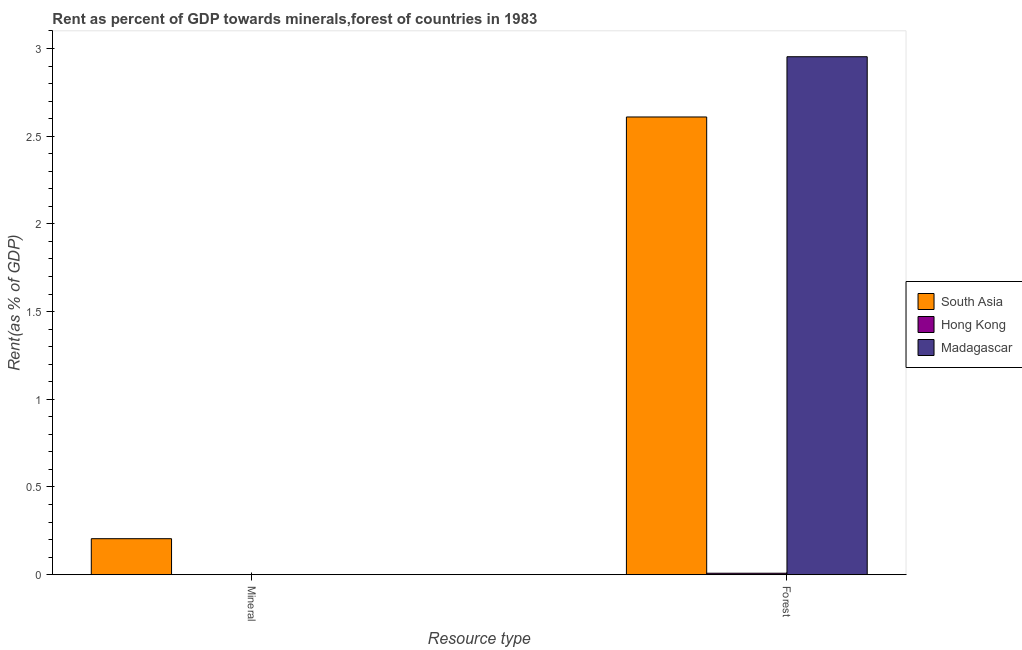How many different coloured bars are there?
Your response must be concise. 3. How many groups of bars are there?
Make the answer very short. 2. Are the number of bars on each tick of the X-axis equal?
Your answer should be very brief. Yes. How many bars are there on the 2nd tick from the left?
Your answer should be very brief. 3. How many bars are there on the 1st tick from the right?
Make the answer very short. 3. What is the label of the 1st group of bars from the left?
Ensure brevity in your answer.  Mineral. What is the forest rent in South Asia?
Your response must be concise. 2.61. Across all countries, what is the maximum mineral rent?
Ensure brevity in your answer.  0.21. Across all countries, what is the minimum forest rent?
Offer a terse response. 0.01. In which country was the mineral rent maximum?
Your answer should be very brief. South Asia. In which country was the forest rent minimum?
Give a very brief answer. Hong Kong. What is the total forest rent in the graph?
Offer a terse response. 5.57. What is the difference between the forest rent in Hong Kong and that in Madagascar?
Provide a succinct answer. -2.94. What is the difference between the forest rent in Madagascar and the mineral rent in Hong Kong?
Give a very brief answer. 2.95. What is the average mineral rent per country?
Give a very brief answer. 0.07. What is the difference between the mineral rent and forest rent in Hong Kong?
Your answer should be compact. -0.01. What is the ratio of the forest rent in Madagascar to that in Hong Kong?
Offer a terse response. 354.67. Is the mineral rent in Hong Kong less than that in Madagascar?
Ensure brevity in your answer.  Yes. What does the 1st bar from the right in Forest represents?
Provide a succinct answer. Madagascar. How many bars are there?
Your response must be concise. 6. Are all the bars in the graph horizontal?
Your answer should be very brief. No. How many countries are there in the graph?
Give a very brief answer. 3. What is the difference between two consecutive major ticks on the Y-axis?
Ensure brevity in your answer.  0.5. Are the values on the major ticks of Y-axis written in scientific E-notation?
Offer a terse response. No. Does the graph contain any zero values?
Your answer should be very brief. No. Does the graph contain grids?
Offer a terse response. No. How are the legend labels stacked?
Keep it short and to the point. Vertical. What is the title of the graph?
Your answer should be compact. Rent as percent of GDP towards minerals,forest of countries in 1983. Does "High income: OECD" appear as one of the legend labels in the graph?
Offer a terse response. No. What is the label or title of the X-axis?
Offer a very short reply. Resource type. What is the label or title of the Y-axis?
Provide a short and direct response. Rent(as % of GDP). What is the Rent(as % of GDP) in South Asia in Mineral?
Ensure brevity in your answer.  0.21. What is the Rent(as % of GDP) of Hong Kong in Mineral?
Ensure brevity in your answer.  0. What is the Rent(as % of GDP) of Madagascar in Mineral?
Give a very brief answer. 0. What is the Rent(as % of GDP) in South Asia in Forest?
Offer a terse response. 2.61. What is the Rent(as % of GDP) in Hong Kong in Forest?
Your answer should be compact. 0.01. What is the Rent(as % of GDP) in Madagascar in Forest?
Keep it short and to the point. 2.95. Across all Resource type, what is the maximum Rent(as % of GDP) of South Asia?
Provide a short and direct response. 2.61. Across all Resource type, what is the maximum Rent(as % of GDP) of Hong Kong?
Make the answer very short. 0.01. Across all Resource type, what is the maximum Rent(as % of GDP) of Madagascar?
Keep it short and to the point. 2.95. Across all Resource type, what is the minimum Rent(as % of GDP) of South Asia?
Your answer should be compact. 0.21. Across all Resource type, what is the minimum Rent(as % of GDP) of Hong Kong?
Ensure brevity in your answer.  0. Across all Resource type, what is the minimum Rent(as % of GDP) of Madagascar?
Your answer should be compact. 0. What is the total Rent(as % of GDP) in South Asia in the graph?
Your answer should be compact. 2.81. What is the total Rent(as % of GDP) of Hong Kong in the graph?
Ensure brevity in your answer.  0.01. What is the total Rent(as % of GDP) in Madagascar in the graph?
Offer a very short reply. 2.95. What is the difference between the Rent(as % of GDP) in South Asia in Mineral and that in Forest?
Ensure brevity in your answer.  -2.4. What is the difference between the Rent(as % of GDP) of Hong Kong in Mineral and that in Forest?
Ensure brevity in your answer.  -0.01. What is the difference between the Rent(as % of GDP) of Madagascar in Mineral and that in Forest?
Provide a succinct answer. -2.95. What is the difference between the Rent(as % of GDP) in South Asia in Mineral and the Rent(as % of GDP) in Hong Kong in Forest?
Give a very brief answer. 0.2. What is the difference between the Rent(as % of GDP) of South Asia in Mineral and the Rent(as % of GDP) of Madagascar in Forest?
Your answer should be compact. -2.75. What is the difference between the Rent(as % of GDP) of Hong Kong in Mineral and the Rent(as % of GDP) of Madagascar in Forest?
Provide a short and direct response. -2.95. What is the average Rent(as % of GDP) in South Asia per Resource type?
Give a very brief answer. 1.41. What is the average Rent(as % of GDP) of Hong Kong per Resource type?
Offer a very short reply. 0. What is the average Rent(as % of GDP) in Madagascar per Resource type?
Make the answer very short. 1.48. What is the difference between the Rent(as % of GDP) of South Asia and Rent(as % of GDP) of Hong Kong in Mineral?
Give a very brief answer. 0.2. What is the difference between the Rent(as % of GDP) in South Asia and Rent(as % of GDP) in Madagascar in Mineral?
Offer a very short reply. 0.2. What is the difference between the Rent(as % of GDP) of Hong Kong and Rent(as % of GDP) of Madagascar in Mineral?
Provide a short and direct response. -0. What is the difference between the Rent(as % of GDP) of South Asia and Rent(as % of GDP) of Hong Kong in Forest?
Make the answer very short. 2.6. What is the difference between the Rent(as % of GDP) in South Asia and Rent(as % of GDP) in Madagascar in Forest?
Offer a terse response. -0.34. What is the difference between the Rent(as % of GDP) of Hong Kong and Rent(as % of GDP) of Madagascar in Forest?
Give a very brief answer. -2.94. What is the ratio of the Rent(as % of GDP) of South Asia in Mineral to that in Forest?
Give a very brief answer. 0.08. What is the ratio of the Rent(as % of GDP) in Hong Kong in Mineral to that in Forest?
Offer a very short reply. 0.05. What is the ratio of the Rent(as % of GDP) of Madagascar in Mineral to that in Forest?
Offer a very short reply. 0. What is the difference between the highest and the second highest Rent(as % of GDP) in South Asia?
Your response must be concise. 2.4. What is the difference between the highest and the second highest Rent(as % of GDP) of Hong Kong?
Offer a very short reply. 0.01. What is the difference between the highest and the second highest Rent(as % of GDP) in Madagascar?
Your answer should be compact. 2.95. What is the difference between the highest and the lowest Rent(as % of GDP) of South Asia?
Offer a very short reply. 2.4. What is the difference between the highest and the lowest Rent(as % of GDP) of Hong Kong?
Offer a very short reply. 0.01. What is the difference between the highest and the lowest Rent(as % of GDP) in Madagascar?
Provide a short and direct response. 2.95. 